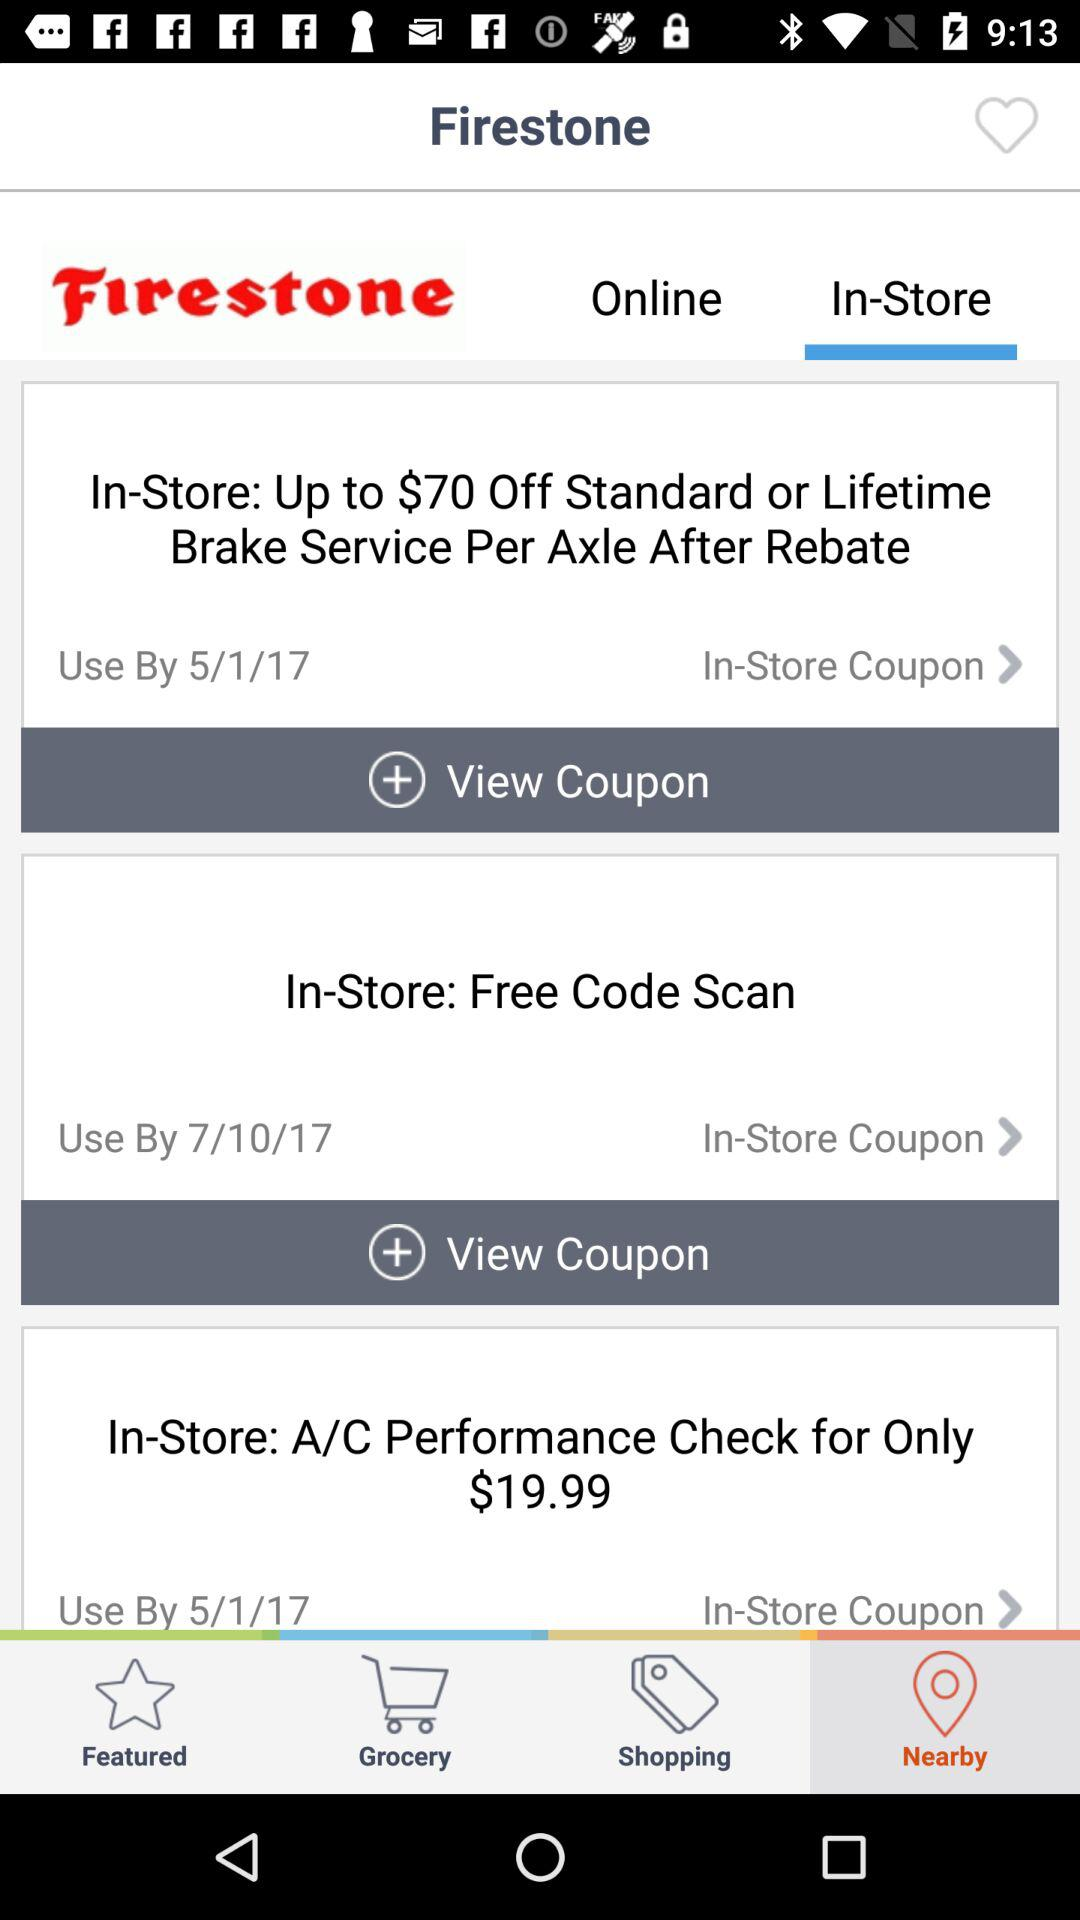Which tab is selected? The selected tab is "Nearby". 